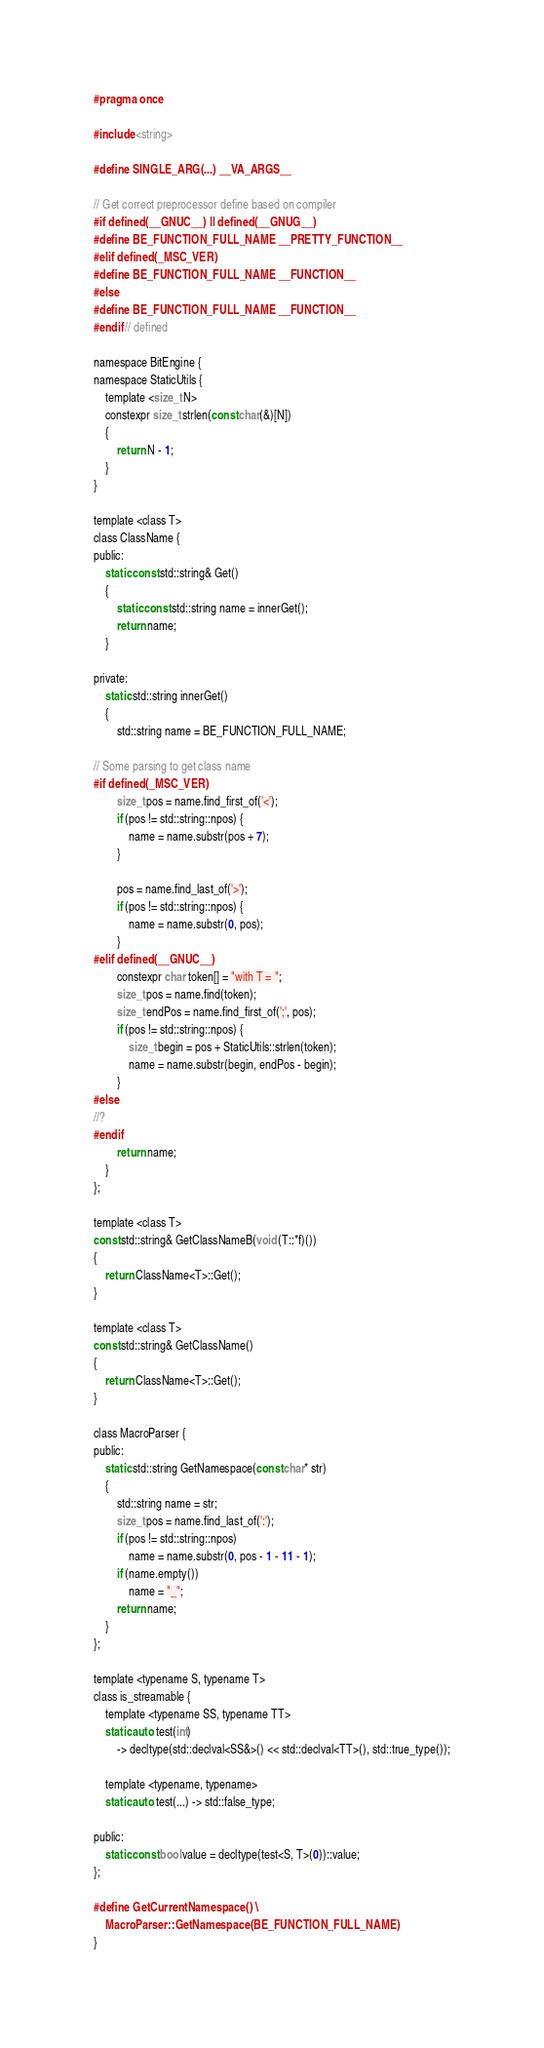<code> <loc_0><loc_0><loc_500><loc_500><_C_>#pragma once

#include <string>

#define SINGLE_ARG(...) __VA_ARGS__

// Get correct preprocessor define based on compiler
#if defined(__GNUC__) || defined(__GNUG__)
#define BE_FUNCTION_FULL_NAME __PRETTY_FUNCTION__
#elif defined(_MSC_VER)
#define BE_FUNCTION_FULL_NAME __FUNCTION__
#else
#define BE_FUNCTION_FULL_NAME __FUNCTION__
#endif // defined

namespace BitEngine {
namespace StaticUtils {
    template <size_t N>
    constexpr size_t strlen(const char(&)[N])
    {
        return N - 1;
    }
}

template <class T>
class ClassName {
public:
    static const std::string& Get()
    {
        static const std::string name = innerGet();
        return name;
    }

private:
    static std::string innerGet()
    {
        std::string name = BE_FUNCTION_FULL_NAME;

// Some parsing to get class name
#if defined(_MSC_VER)
        size_t pos = name.find_first_of('<');
        if (pos != std::string::npos) {
            name = name.substr(pos + 7);
        }

        pos = name.find_last_of('>');
        if (pos != std::string::npos) {
            name = name.substr(0, pos);
        }
#elif defined(__GNUC__)
        constexpr char token[] = "with T = ";
        size_t pos = name.find(token);
        size_t endPos = name.find_first_of(';', pos);
        if (pos != std::string::npos) {
            size_t begin = pos + StaticUtils::strlen(token);
            name = name.substr(begin, endPos - begin);
        }
#else
//?
#endif
        return name;
    }
};

template <class T>
const std::string& GetClassNameB(void (T::*f)())
{
    return ClassName<T>::Get();
}

template <class T>
const std::string& GetClassName()
{
    return ClassName<T>::Get();
}

class MacroParser {
public:
    static std::string GetNamespace(const char* str)
    {
        std::string name = str;
        size_t pos = name.find_last_of(':');
        if (pos != std::string::npos)
            name = name.substr(0, pos - 1 - 11 - 1);
        if (name.empty())
            name = "_";
        return name;
    }
};

template <typename S, typename T>
class is_streamable {
    template <typename SS, typename TT>
    static auto test(int)
        -> decltype(std::declval<SS&>() << std::declval<TT>(), std::true_type());

    template <typename, typename>
    static auto test(...) -> std::false_type;

public:
    static const bool value = decltype(test<S, T>(0))::value;
};

#define GetCurrentNamespace() \
    MacroParser::GetNamespace(BE_FUNCTION_FULL_NAME)
}
</code> 